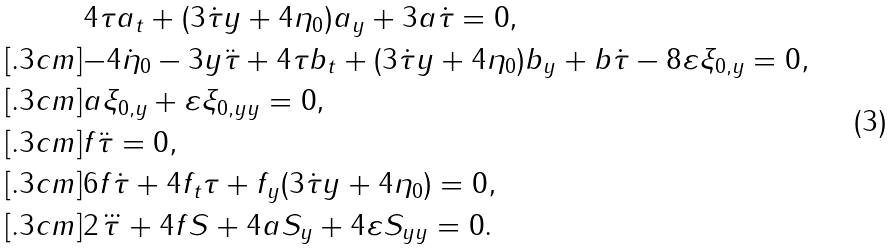<formula> <loc_0><loc_0><loc_500><loc_500>& { 4 \tau a _ { t } + ( 3 \dot { \tau } y + 4 \eta _ { 0 } ) a _ { y } + 3 a \dot { \tau } = 0 } , \\ [ . 3 c m ] & { - 4 \dot { \eta } _ { 0 } - 3 y \ddot { \tau } + 4 \tau b _ { t } + ( 3 \dot { \tau } y + 4 \eta _ { 0 } ) b _ { y } + b \dot { \tau } - 8 \varepsilon \xi _ { 0 , y } = 0 } , \\ [ . 3 c m ] & { a \xi _ { 0 , y } + \varepsilon \xi _ { 0 , y y } = 0 } , \\ [ . 3 c m ] & { f \ddot { \tau } = 0 } , \\ [ . 3 c m ] & { 6 f \dot { \tau } + 4 f _ { t } \tau + f _ { y } ( 3 \dot { \tau } y + 4 \eta _ { 0 } ) = 0 } , \\ [ . 3 c m ] & { 2 \dddot { \tau } + 4 f S + 4 a S _ { y } + 4 \varepsilon S _ { y y } = 0 } .</formula> 